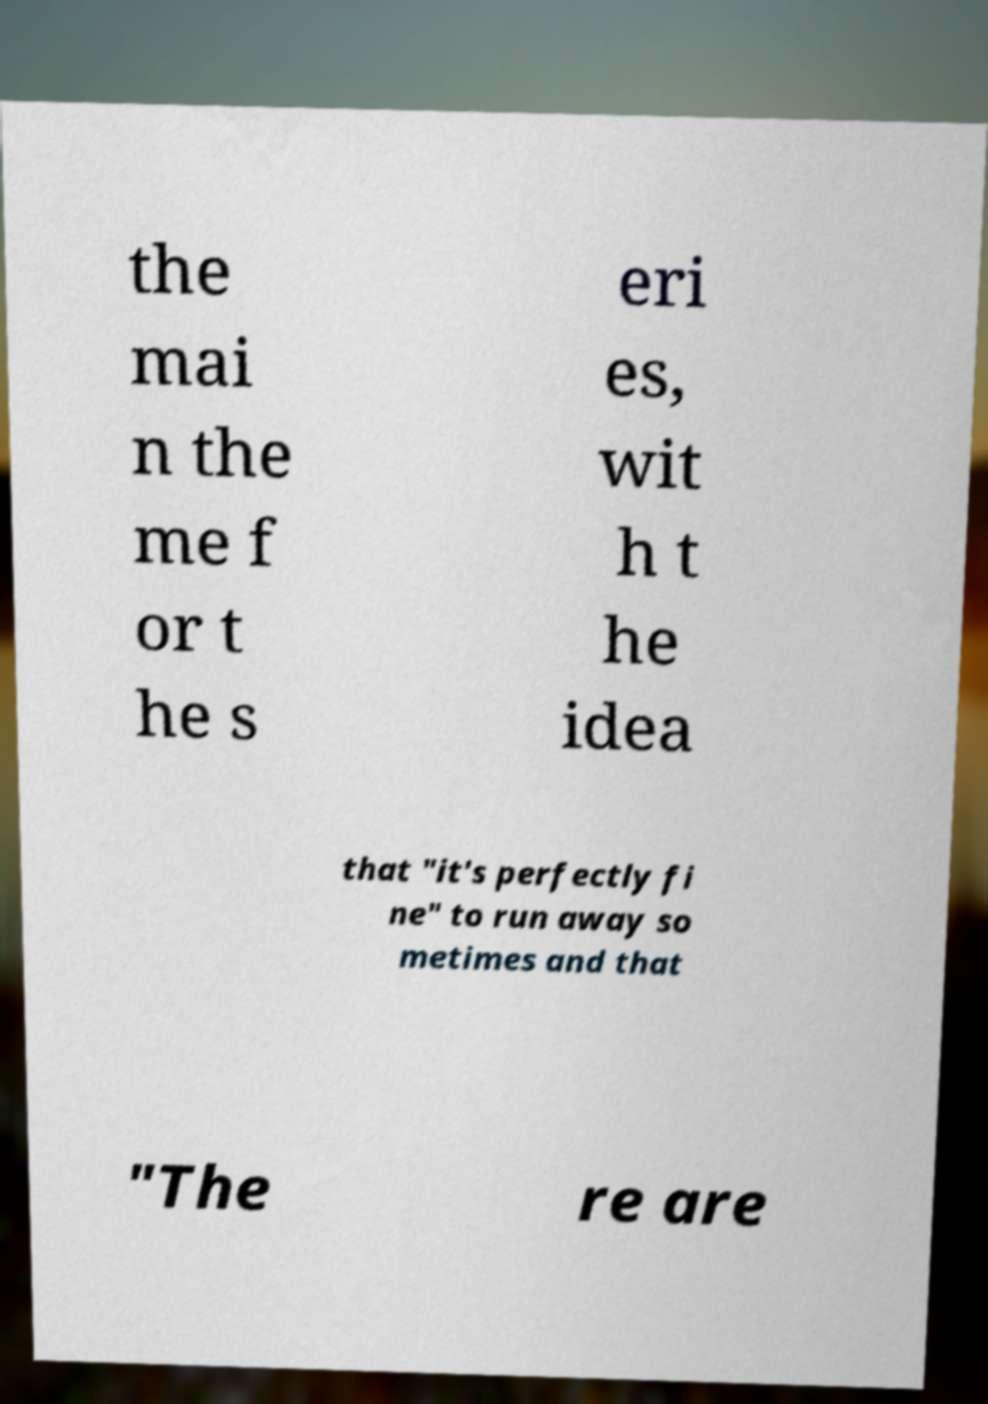Please read and relay the text visible in this image. What does it say? the mai n the me f or t he s eri es, wit h t he idea that "it's perfectly fi ne" to run away so metimes and that "The re are 